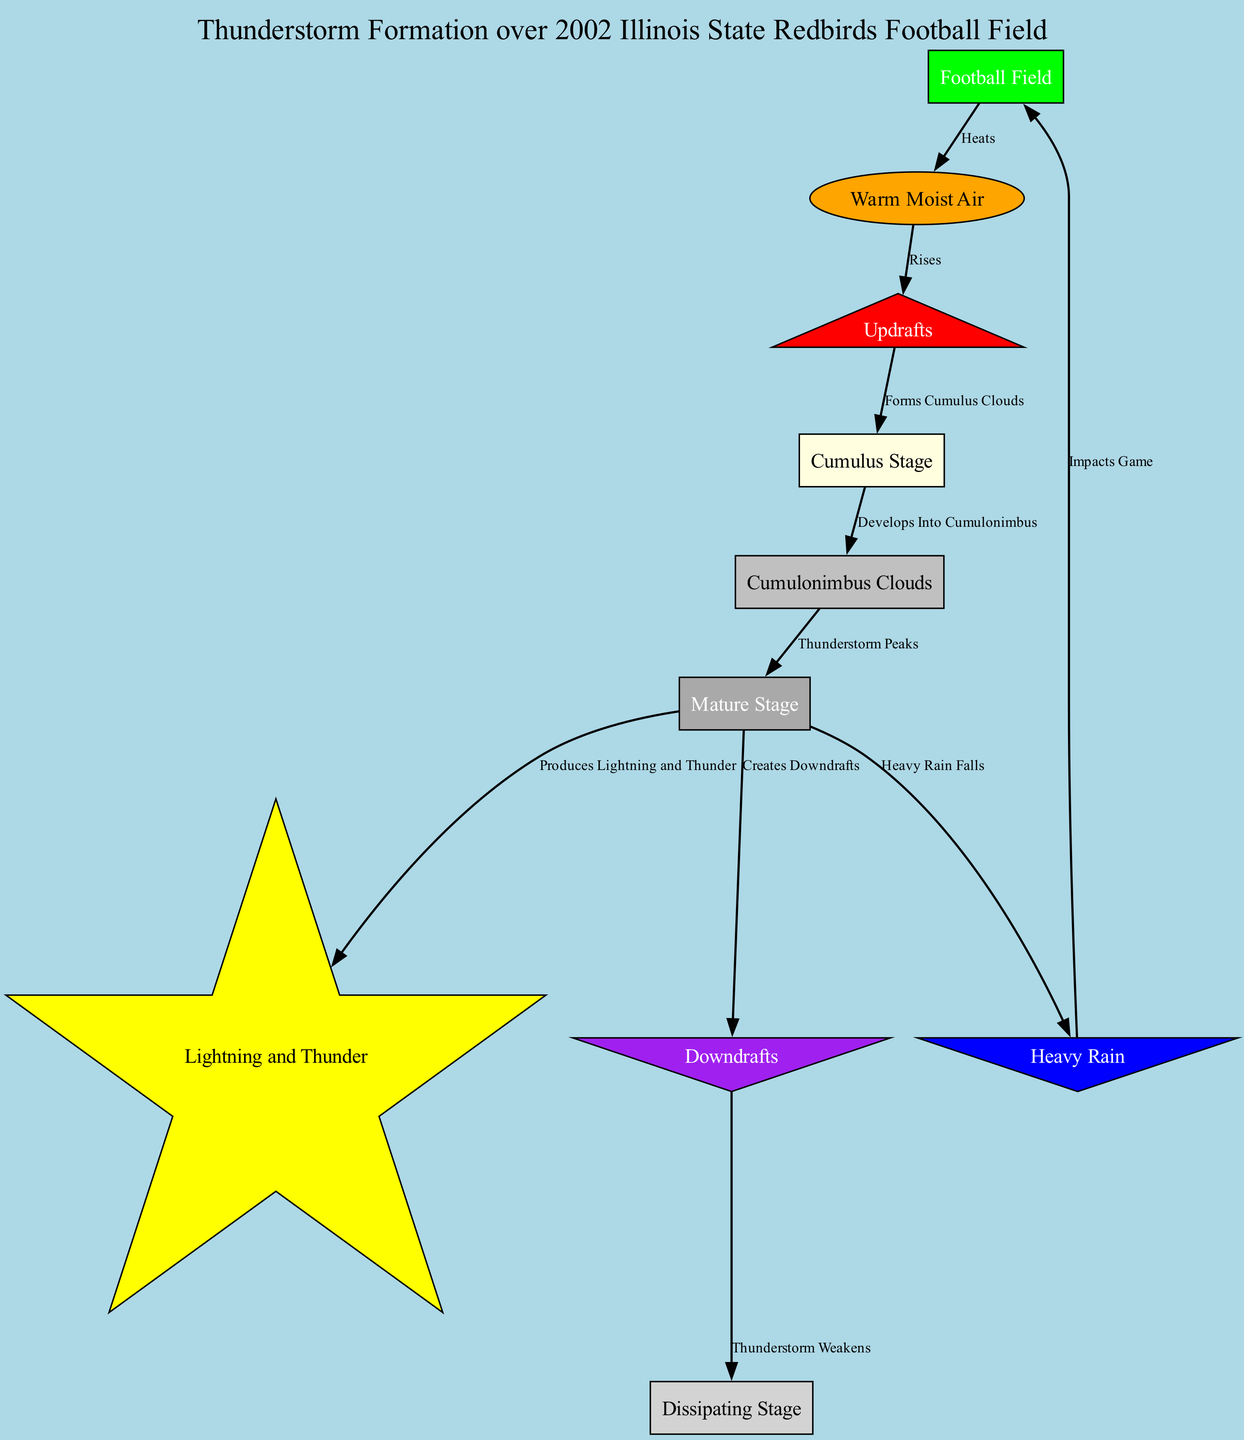What is the first stage of the thunderstorm? The diagram shows the stages of a thunderstorm, and the first one listed is the "Cumulus Stage."
Answer: Cumulus Stage How many edges are in the diagram? By counting the connections between the nodes (edges), there are 10 edges in total.
Answer: 10 What type of clouds form during the mature stage? The diagram specifies that cumulonimbus clouds develop and peak during the mature stage.
Answer: Cumulonimbus Clouds What impacts the game according to the diagram? The flow shows that heavy rain falls during the mature stage and connects directly to the football field, indicating the impact on the game.
Answer: Heavy Rain During which stage does lightning and thunder occur? The arrow from the mature stage to the lightning and thunder node indicates that this weather phenomenon occurs during the mature stage.
Answer: Mature Stage What causes warm moist air to rise? The diagram illustrates that warm moist air is heated by the football field, which causes it to rise and create updrafts.
Answer: Heated by the field What happens when downdrafts occur? The diagram shows that downdrafts contribute to the dissipating stage, indicating the weakening of the thunderstorm.
Answer: Thunderstorm Weakens Which node describes the severe weather observed? The diagram has a specific node labeled "Lightning and Thunder," which reflects the severe weather phenomena observed.
Answer: Lightning and Thunder What leads to the formation of cumulus clouds? The updrafts, which are created by rising warm moist air, lead to the formation of cumulus clouds in the cumulus stage.
Answer: Updrafts What stage follows the mature stage? The flow in the diagram shows that following the mature stage, the thunderstorm transitions into the dissipating stage.
Answer: Dissipating Stage 